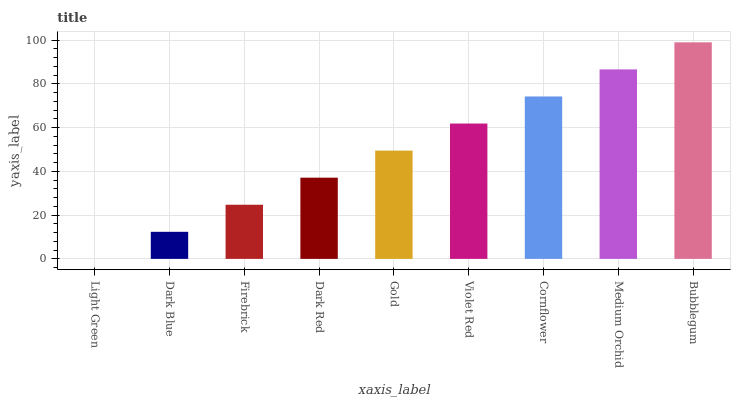Is Light Green the minimum?
Answer yes or no. Yes. Is Bubblegum the maximum?
Answer yes or no. Yes. Is Dark Blue the minimum?
Answer yes or no. No. Is Dark Blue the maximum?
Answer yes or no. No. Is Dark Blue greater than Light Green?
Answer yes or no. Yes. Is Light Green less than Dark Blue?
Answer yes or no. Yes. Is Light Green greater than Dark Blue?
Answer yes or no. No. Is Dark Blue less than Light Green?
Answer yes or no. No. Is Gold the high median?
Answer yes or no. Yes. Is Gold the low median?
Answer yes or no. Yes. Is Light Green the high median?
Answer yes or no. No. Is Firebrick the low median?
Answer yes or no. No. 